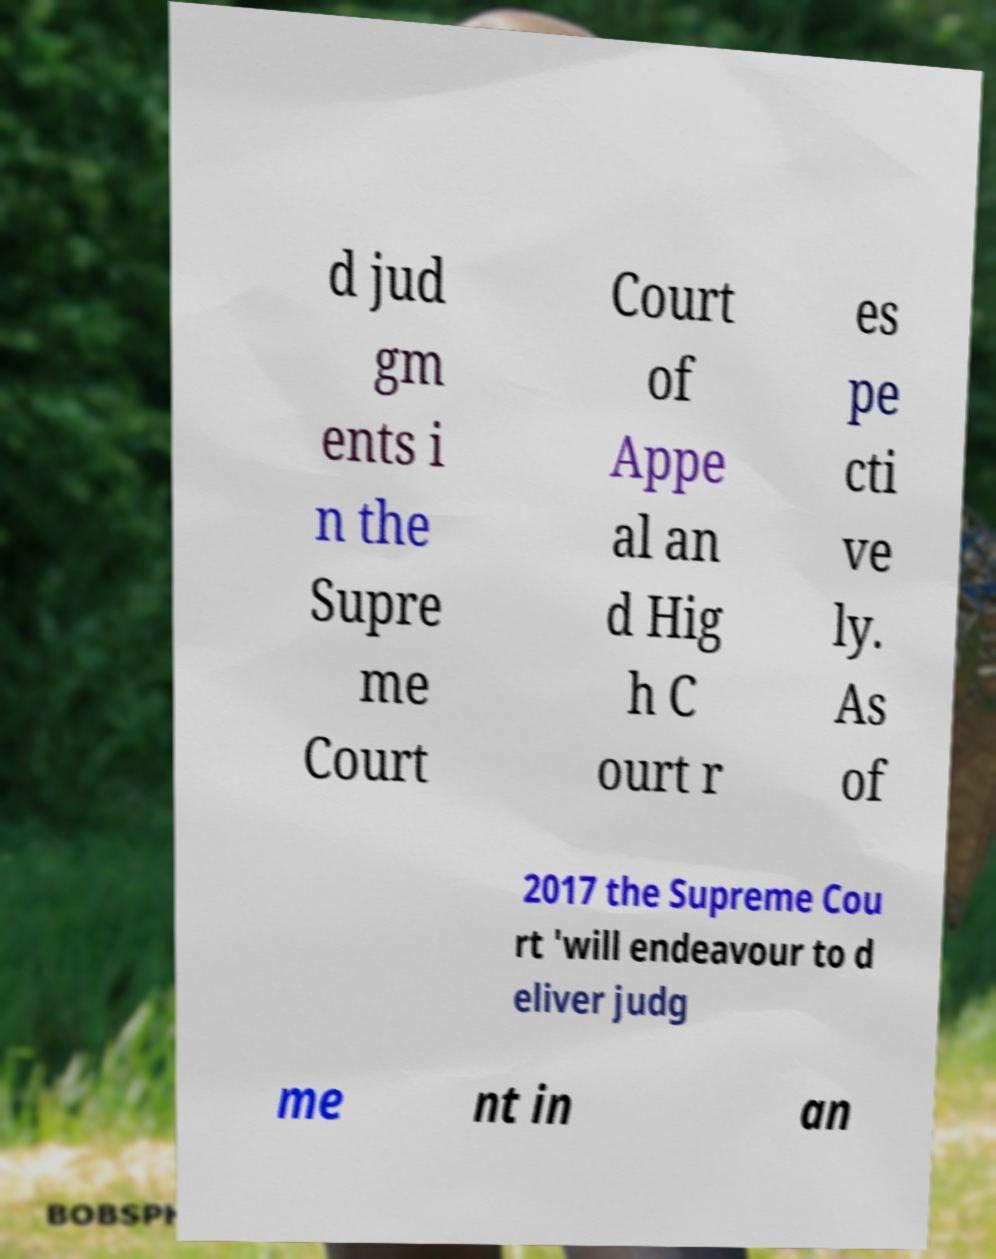I need the written content from this picture converted into text. Can you do that? d jud gm ents i n the Supre me Court Court of Appe al an d Hig h C ourt r es pe cti ve ly. As of 2017 the Supreme Cou rt 'will endeavour to d eliver judg me nt in an 